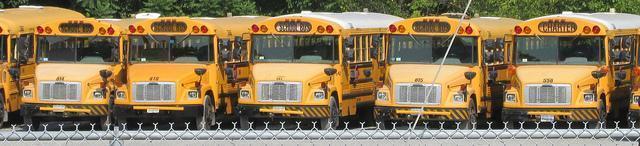How many buses are in this photo?
Give a very brief answer. 6. How many buses are there?
Give a very brief answer. 6. 